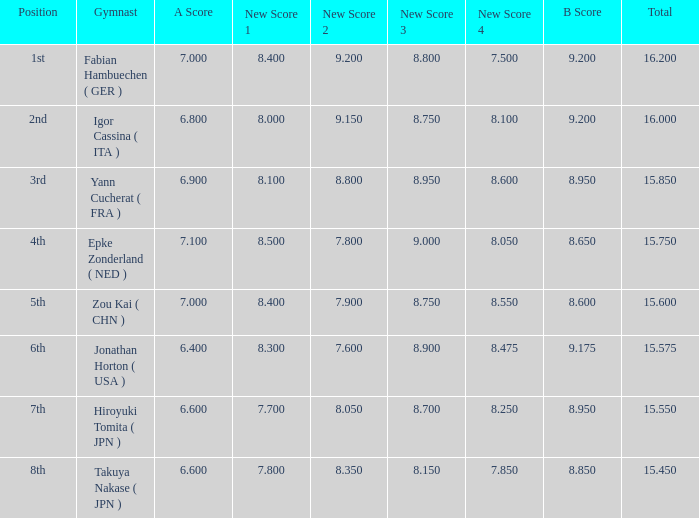Which gymnast had a b score of 8.95 and an a score less than 6.9 Hiroyuki Tomita ( JPN ). 